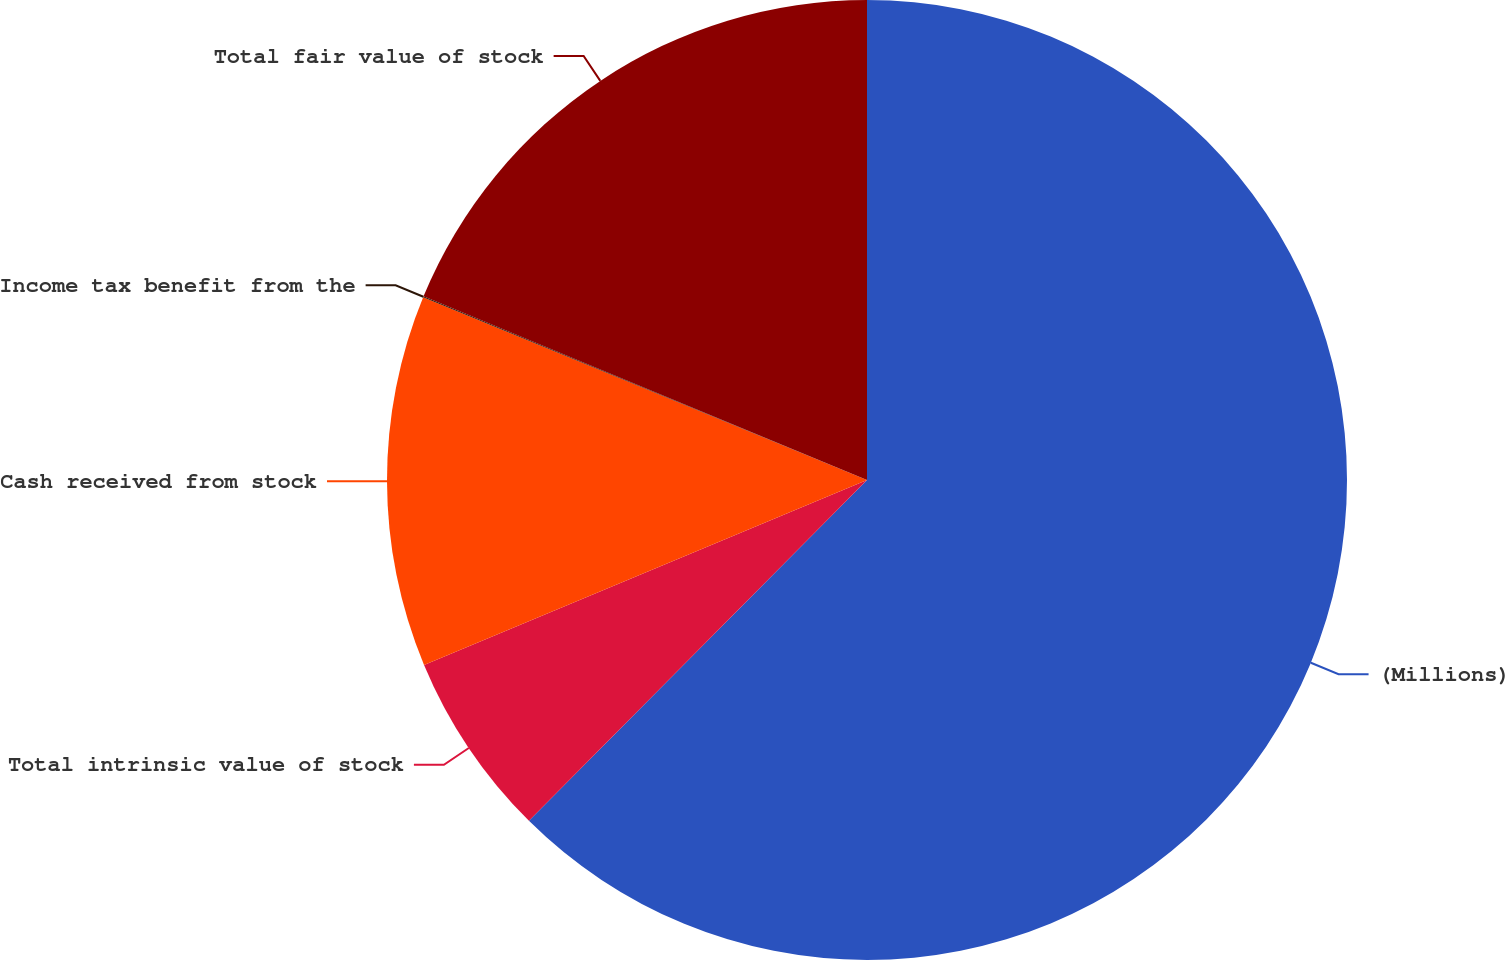<chart> <loc_0><loc_0><loc_500><loc_500><pie_chart><fcel>(Millions)<fcel>Total intrinsic value of stock<fcel>Cash received from stock<fcel>Income tax benefit from the<fcel>Total fair value of stock<nl><fcel>62.43%<fcel>6.27%<fcel>12.51%<fcel>0.03%<fcel>18.75%<nl></chart> 